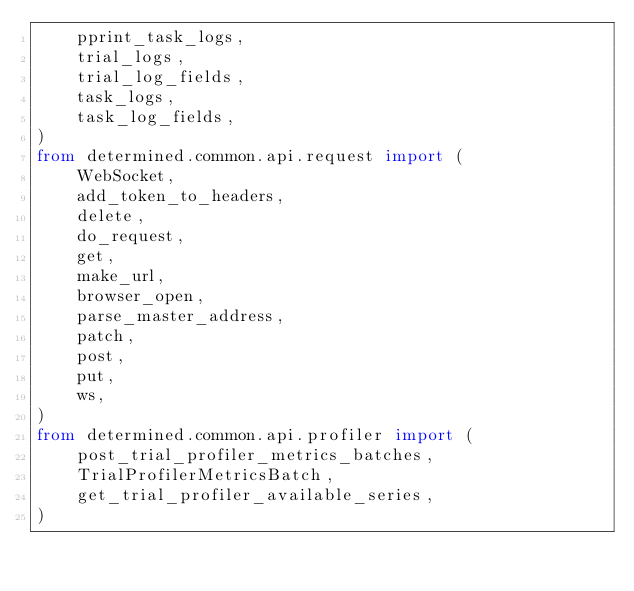Convert code to text. <code><loc_0><loc_0><loc_500><loc_500><_Python_>    pprint_task_logs,
    trial_logs,
    trial_log_fields,
    task_logs,
    task_log_fields,
)
from determined.common.api.request import (
    WebSocket,
    add_token_to_headers,
    delete,
    do_request,
    get,
    make_url,
    browser_open,
    parse_master_address,
    patch,
    post,
    put,
    ws,
)
from determined.common.api.profiler import (
    post_trial_profiler_metrics_batches,
    TrialProfilerMetricsBatch,
    get_trial_profiler_available_series,
)
</code> 